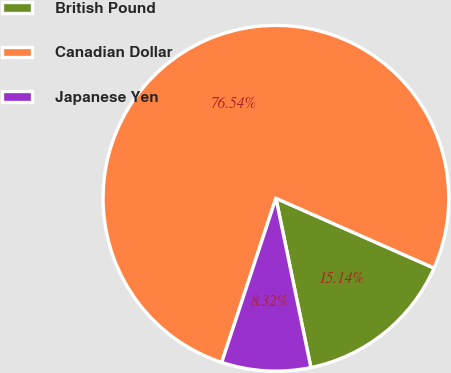<chart> <loc_0><loc_0><loc_500><loc_500><pie_chart><fcel>British Pound<fcel>Canadian Dollar<fcel>Japanese Yen<nl><fcel>15.14%<fcel>76.54%<fcel>8.32%<nl></chart> 